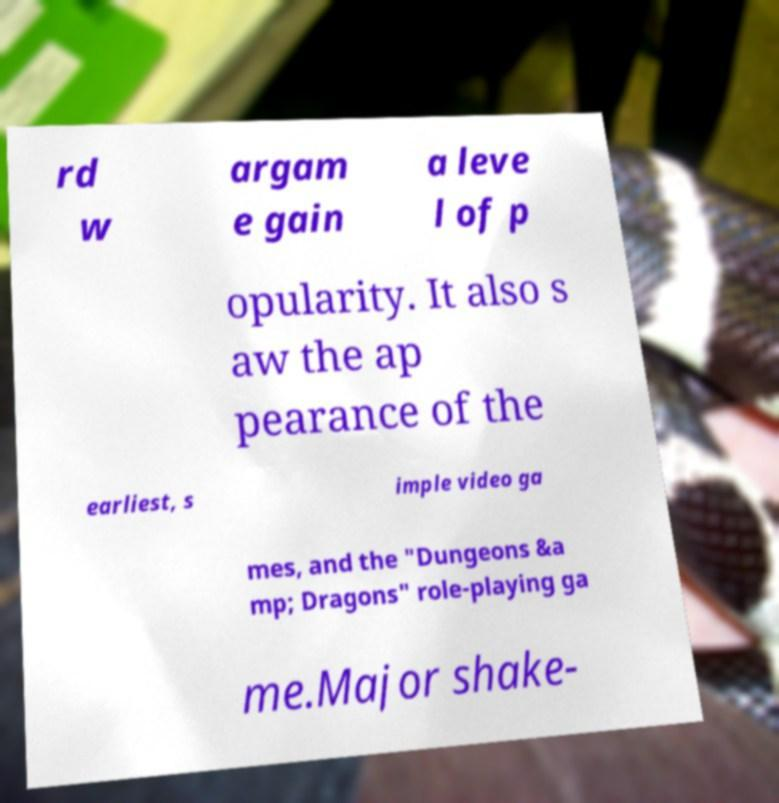What messages or text are displayed in this image? I need them in a readable, typed format. rd w argam e gain a leve l of p opularity. It also s aw the ap pearance of the earliest, s imple video ga mes, and the "Dungeons &a mp; Dragons" role-playing ga me.Major shake- 